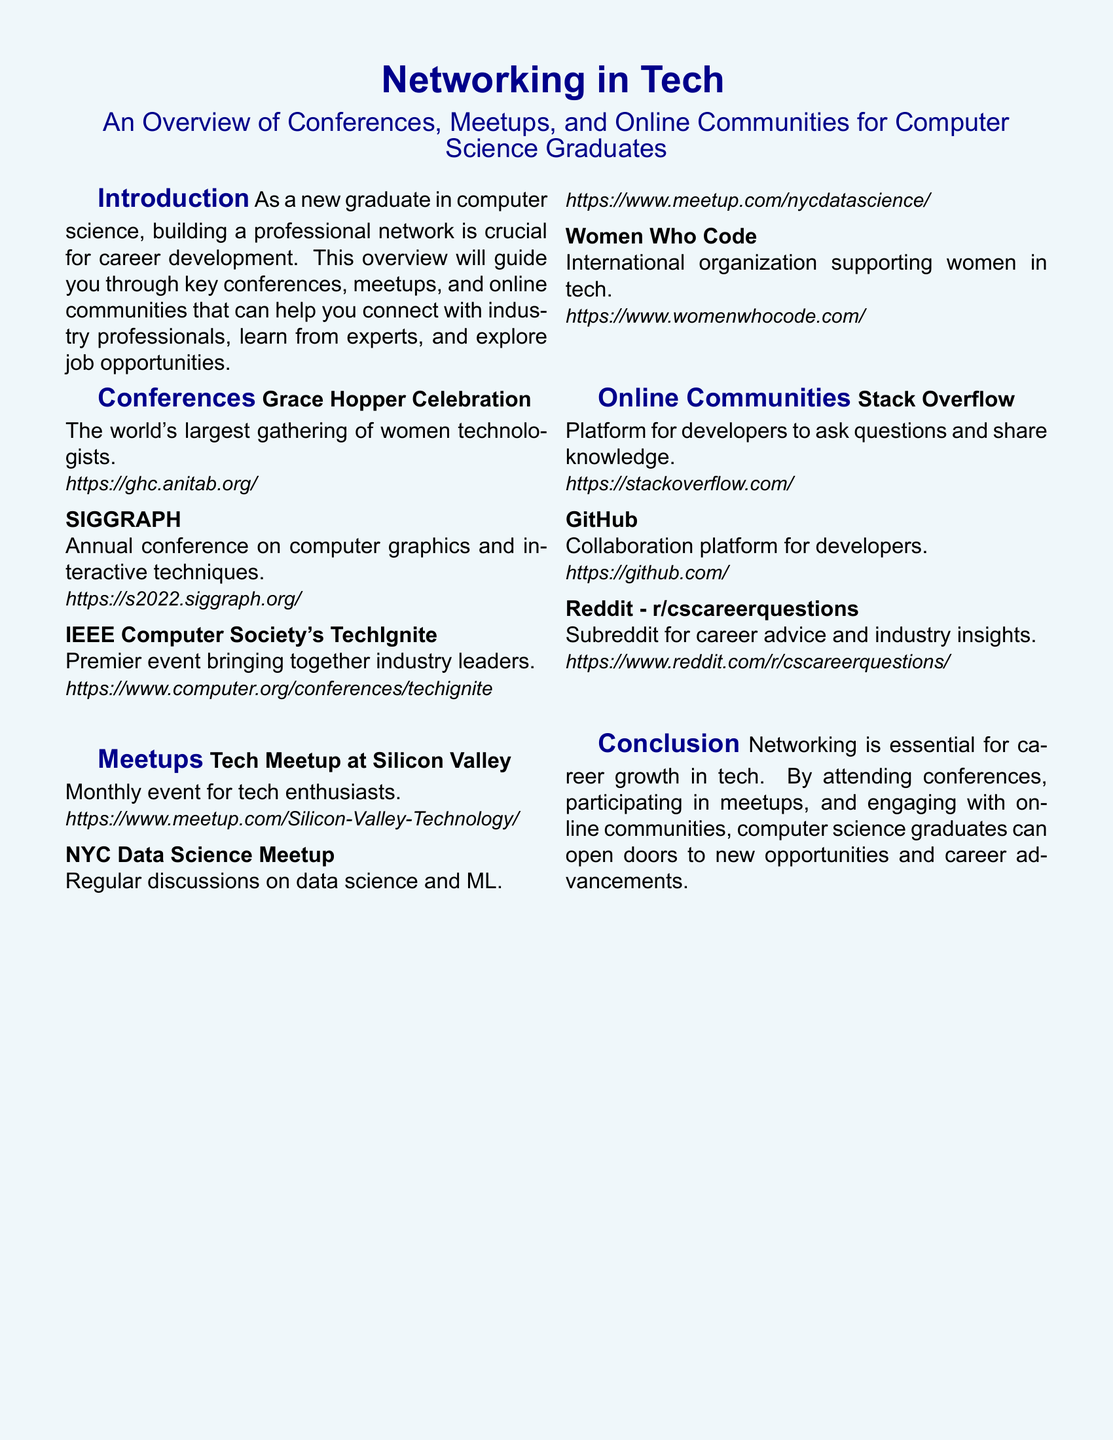What is the largest gathering of women technologists? The document mentions the Grace Hopper Celebration as the world's largest gathering of women technologists.
Answer: Grace Hopper Celebration What is the main purpose of the IEEE Computer Society's TechIgnite? According to the document, this event brings together industry leaders.
Answer: Bringing together industry leaders How often does the Tech Meetup at Silicon Valley occur? The document specifies that it is a monthly event for tech enthusiasts.
Answer: Monthly What online platform is mentioned for asking questions and sharing knowledge among developers? The document indicates that Stack Overflow is the platform for developers.
Answer: Stack Overflow Which community supports women in tech? The document describes Women Who Code as an international organization supporting women in tech.
Answer: Women Who Code How many types of networking opportunities are highlighted in the document? The introduction mentions three types: conferences, meetups, and online communities.
Answer: Three What is the focus of the NYC Data Science Meetup? The document states that it involves regular discussions on data science and machine learning.
Answer: Data science and ML What is the subreddit for career advice and industry insights? The document lists Reddit - r/cscareerquestions as the relevant subreddit.
Answer: r/cscareerquestions Which section contains an overview of key conferences? The document features a section specifically titled "Conferences" for this purpose.
Answer: Conferences 